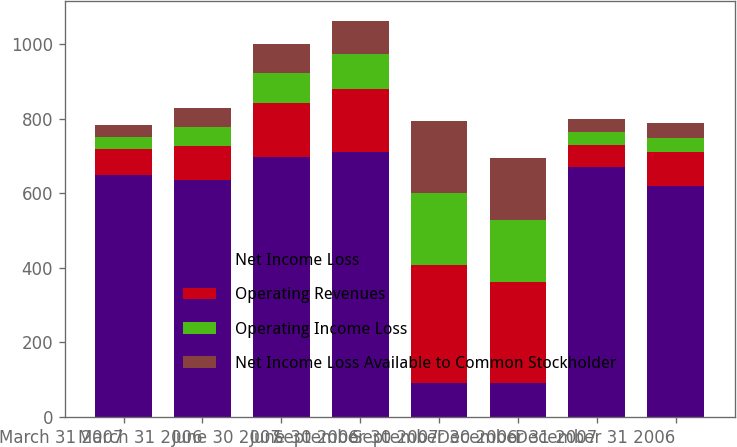Convert chart to OTSL. <chart><loc_0><loc_0><loc_500><loc_500><stacked_bar_chart><ecel><fcel>March 31 2007<fcel>March 31 2006<fcel>June 30 2007<fcel>June 30 2006<fcel>September 30 2007<fcel>September 30 2006<fcel>December 31 2007<fcel>December 31 2006<nl><fcel>Net Income Loss<fcel>650<fcel>636<fcel>697<fcel>710<fcel>91<fcel>91<fcel>669<fcel>620<nl><fcel>Operating Revenues<fcel>68<fcel>90<fcel>144<fcel>170<fcel>317<fcel>271<fcel>61<fcel>89<nl><fcel>Operating Income Loss<fcel>33<fcel>51<fcel>81<fcel>92<fcel>193<fcel>166<fcel>35<fcel>40<nl><fcel>Net Income Loss Available to Common Stockholder<fcel>32<fcel>50<fcel>79<fcel>90<fcel>192<fcel>165<fcel>33<fcel>38<nl></chart> 